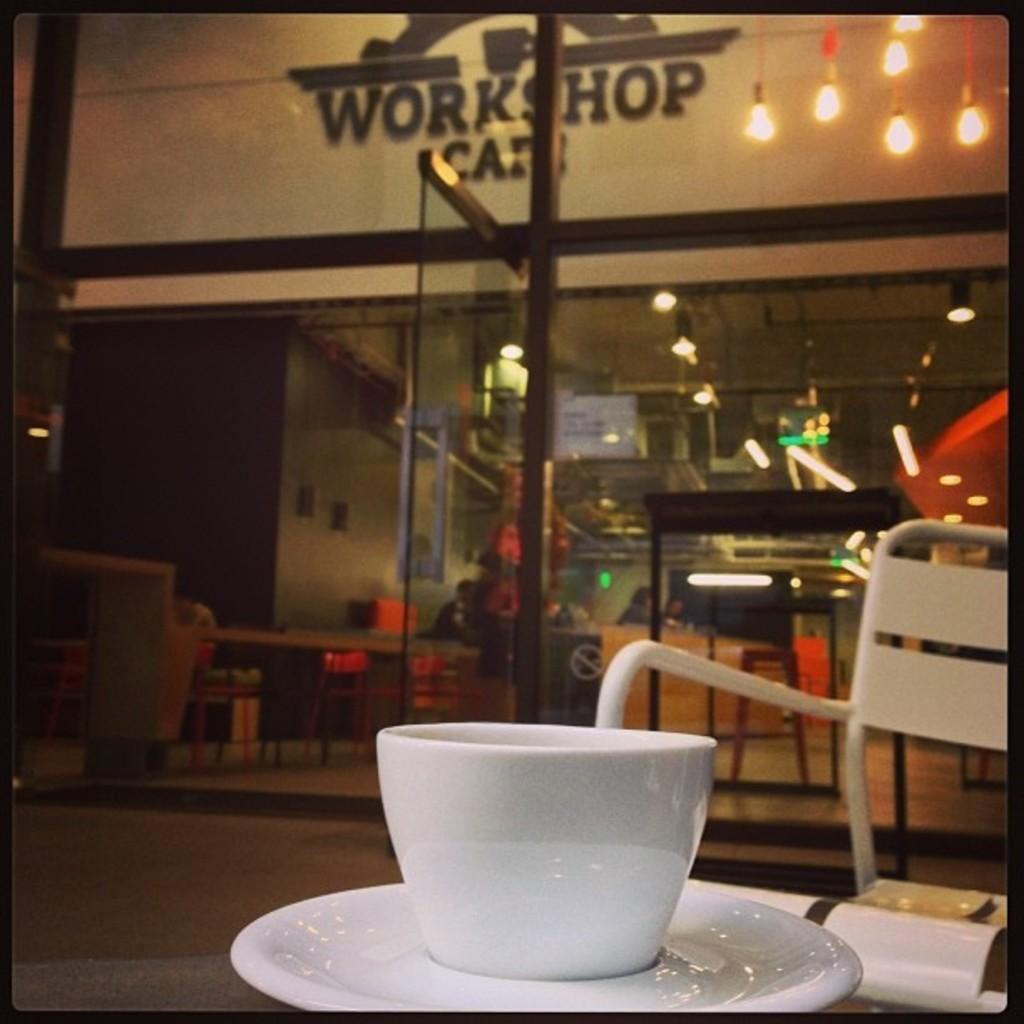<image>
Write a terse but informative summary of the picture. A white teacup is on a saucer under a sign that says Workshop. 